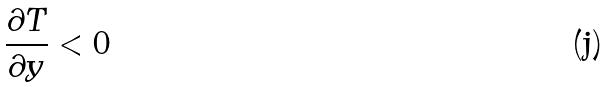Convert formula to latex. <formula><loc_0><loc_0><loc_500><loc_500>\frac { \partial T } { \partial y } < 0</formula> 